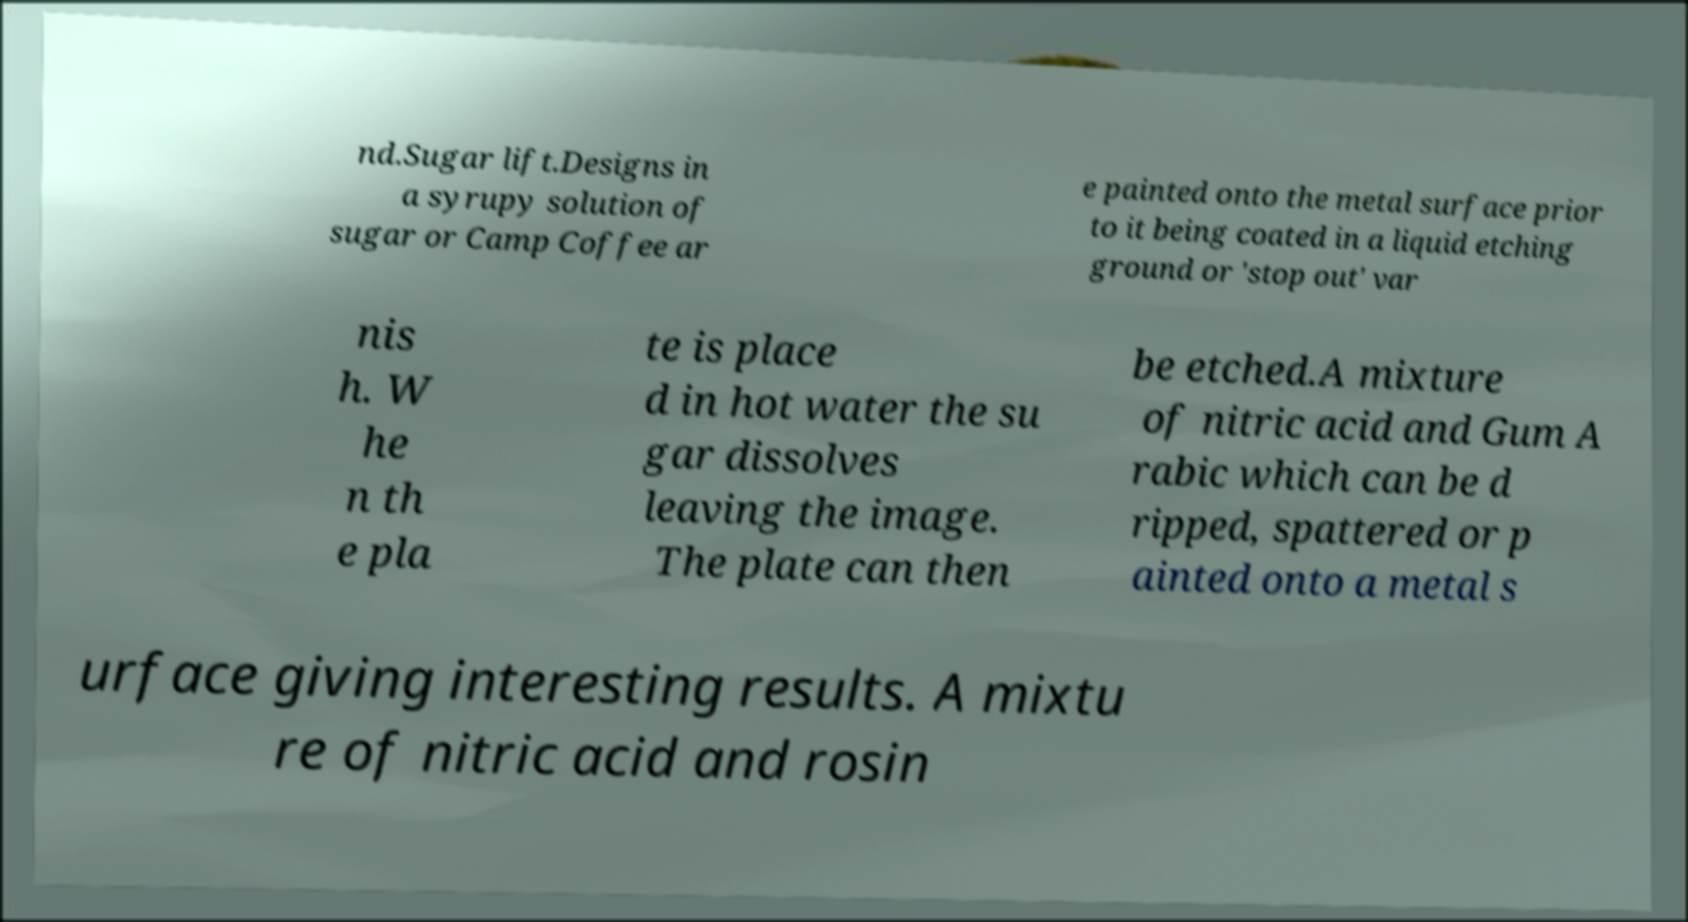Please identify and transcribe the text found in this image. nd.Sugar lift.Designs in a syrupy solution of sugar or Camp Coffee ar e painted onto the metal surface prior to it being coated in a liquid etching ground or 'stop out' var nis h. W he n th e pla te is place d in hot water the su gar dissolves leaving the image. The plate can then be etched.A mixture of nitric acid and Gum A rabic which can be d ripped, spattered or p ainted onto a metal s urface giving interesting results. A mixtu re of nitric acid and rosin 